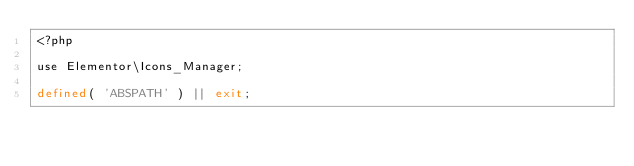Convert code to text. <code><loc_0><loc_0><loc_500><loc_500><_PHP_><?php

use Elementor\Icons_Manager;

defined( 'ABSPATH' ) || exit;
</code> 